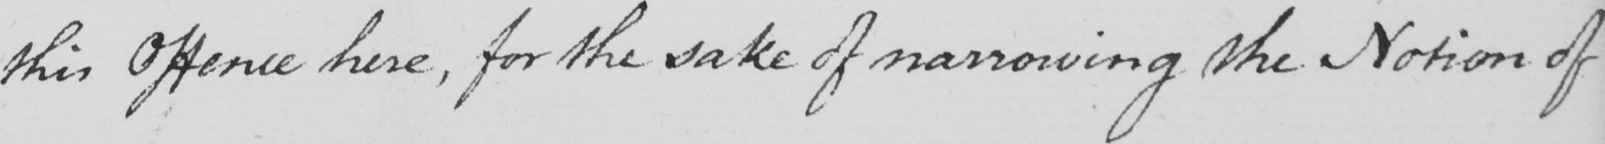Can you read and transcribe this handwriting? this Offence here , for the sake of narrowing the Notion of 